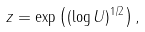Convert formula to latex. <formula><loc_0><loc_0><loc_500><loc_500>z = \exp \left ( ( \log U ) ^ { 1 / 2 } \right ) ,</formula> 